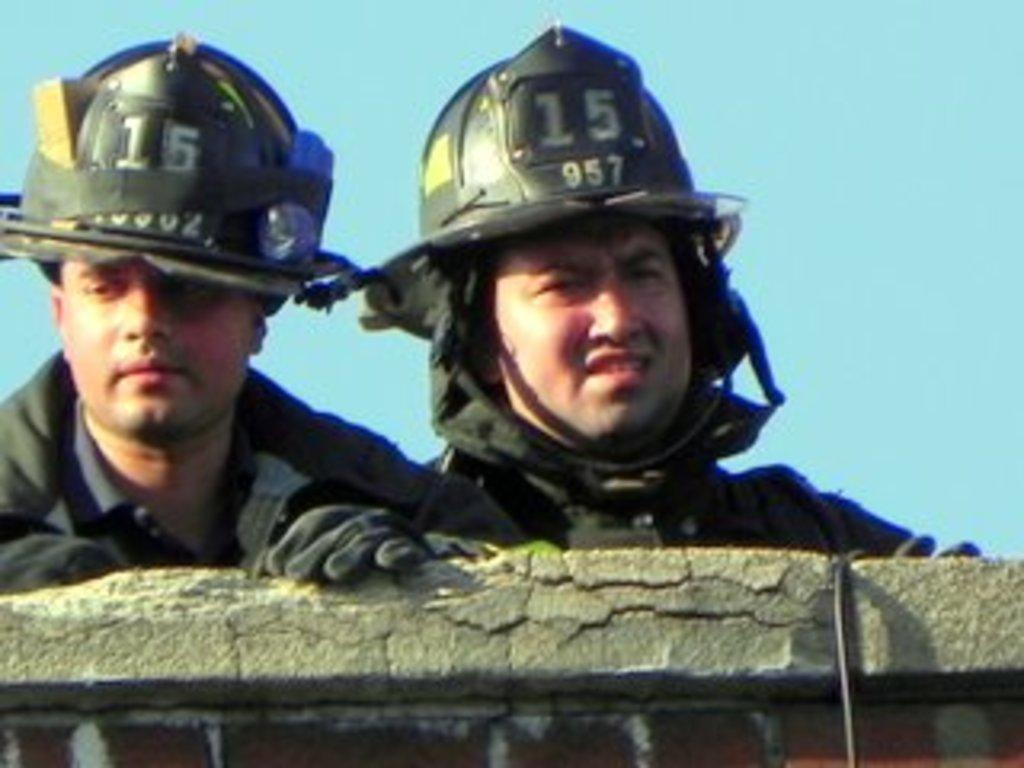Can you describe this image briefly? This image consists of two men wearing helmets and jackets along with gloves. At the bottom, there is a wall. In the background, there is a sky. 